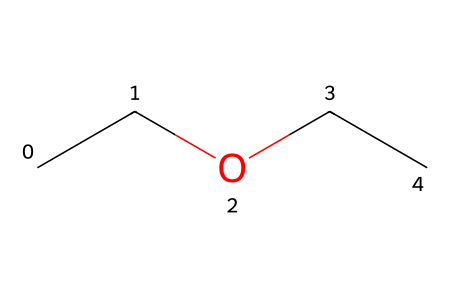What is the name of this chemical? The chemical structure represented by the SMILES "CCOCC" corresponds to diethyl ether, which consists of two ethyl groups attached to an oxygen atom.
Answer: diethyl ether How many carbon atoms are in this structure? The SMILES "CCOCC" indicates the presence of four carbon atoms, as each "C" represents a carbon atom, and there are four "C" in total.
Answer: four How many hydrogen atoms are present in diethyl ether? Each ethyl group (C2H5) has five hydrogen atoms, so with two ethyl groups, there are 10 hydrogen atoms. The oxygen does not contribute any hydrogen, making the total 10.
Answer: ten What type of functional group is present in this chemical? The structure contains an oxygen atom connecting two alkyl groups, which identifies the molecule as an ether, a class of compounds characterized by an R-O-R’ linkage.
Answer: ether What is the overall molecular formula for diethyl ether? To determine the molecular formula, we combine the four carbons (C), ten hydrogens (H), and one oxygen (O), giving us C4H10O. This formula is derived from counting the atoms in the molecule.
Answer: C4H10O What physical state is diethyl ether at room temperature? Diethyl ether is a volatile liquid at room temperature due to its relatively low boiling point, which is around 34.6 degrees Celsius, making it non-viscous and easily evaporated.
Answer: liquid 